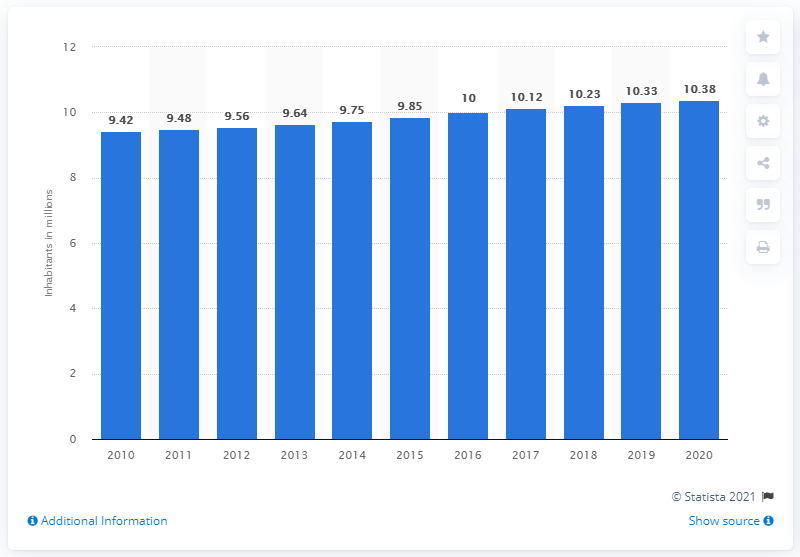Outline some significant characteristics in this image. In 2009, it is estimated that approximately 9.48 million people lived in Sweden. As of the end of 2020, the Swedish population was 10,384,509. 